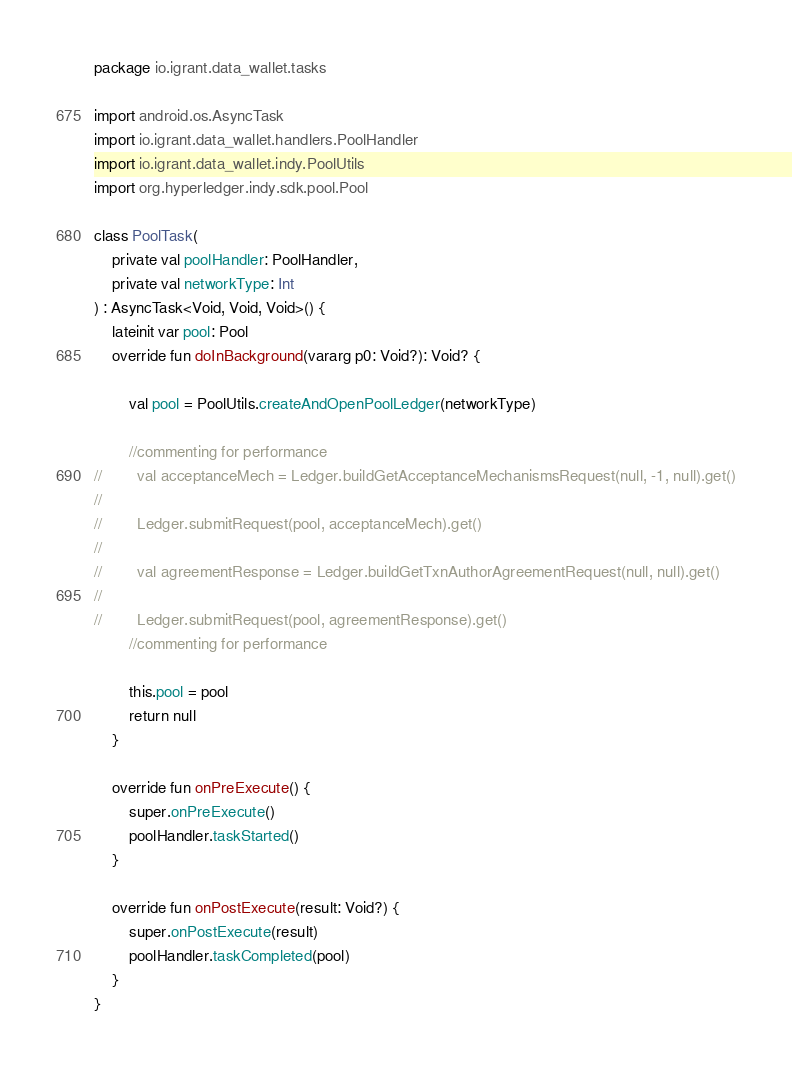<code> <loc_0><loc_0><loc_500><loc_500><_Kotlin_>package io.igrant.data_wallet.tasks

import android.os.AsyncTask
import io.igrant.data_wallet.handlers.PoolHandler
import io.igrant.data_wallet.indy.PoolUtils
import org.hyperledger.indy.sdk.pool.Pool

class PoolTask(
    private val poolHandler: PoolHandler,
    private val networkType: Int
) : AsyncTask<Void, Void, Void>() {
    lateinit var pool: Pool
    override fun doInBackground(vararg p0: Void?): Void? {

        val pool = PoolUtils.createAndOpenPoolLedger(networkType)

        //commenting for performance
//        val acceptanceMech = Ledger.buildGetAcceptanceMechanismsRequest(null, -1, null).get()
//
//        Ledger.submitRequest(pool, acceptanceMech).get()
//
//        val agreementResponse = Ledger.buildGetTxnAuthorAgreementRequest(null, null).get()
//
//        Ledger.submitRequest(pool, agreementResponse).get()
        //commenting for performance

        this.pool = pool
        return null
    }

    override fun onPreExecute() {
        super.onPreExecute()
        poolHandler.taskStarted()
    }

    override fun onPostExecute(result: Void?) {
        super.onPostExecute(result)
        poolHandler.taskCompleted(pool)
    }
}</code> 